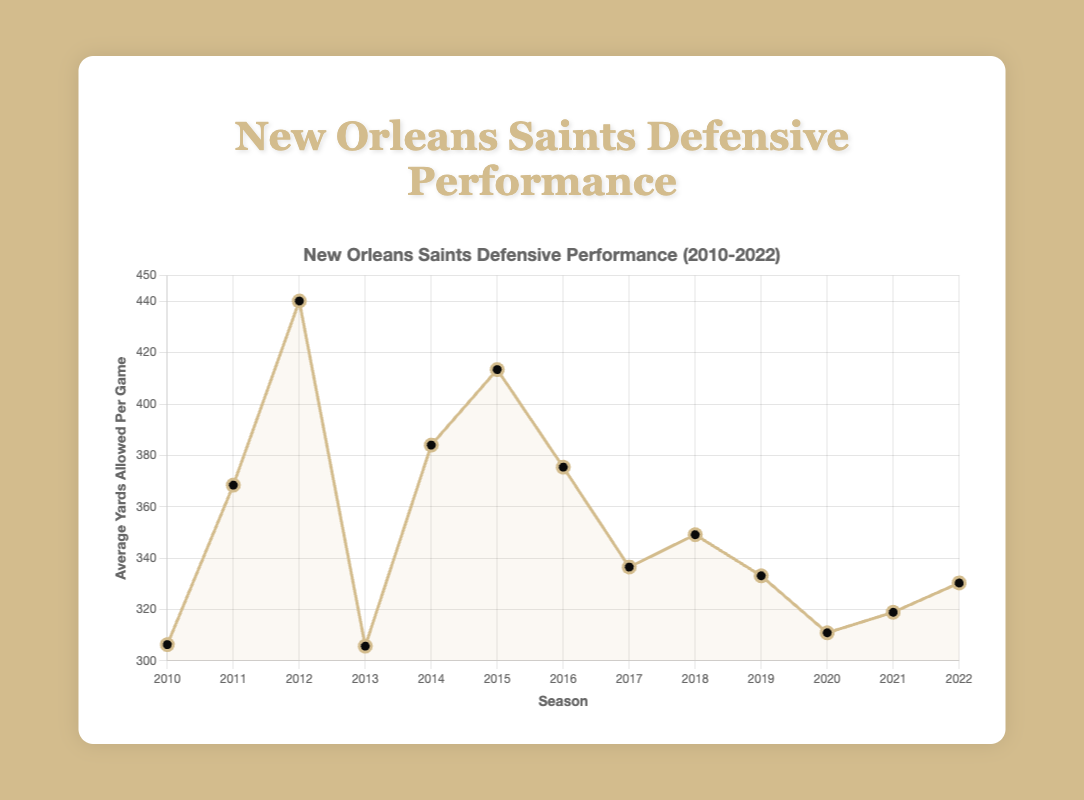What's the season with the highest average yards allowed per game? The highest average yards allowed per game can be found by looking at the peak of the line on the chart, which represents the most yards allowed. The highest point is around the season 2012, showing 440.1 yards per game.
Answer: 2012 Between which two consecutive seasons did the Saints show the most improvement in yards allowed per game? Improvement in yards allowed per game means a decrease in the number of yards allowed. By visually comparing the slopes between adjacent data points, the steepest negative slope (largest drop) is between 2012 and 2013, where the value dropped from 440.1 to 305.7.
Answer: 2012 and 2013 How many seasons did the Saints allow fewer than 320 yards on average per game? This can be calculated by counting the number of data points on the chart that fall below the 320-yard mark. The seasons 2010, 2013, 2020, and 2021 are all below this value.
Answer: 4 By how much did the average yards allowed per game decrease from 2018 to 2019? To find the decrease, subtract the value for 2019 from the value for 2018. The values are 349.1 yards for 2018 and 333.1 yards for 2019, giving \(349.1 - 333.1 = 16\) yards.
Answer: 16 yards What is the average yards allowed per game across all seasons? Add up all the average yards allowed per game for each season, and then divide by the number of seasons (13 total). \((306.3 + 368.4 + 440.1 + 305.7 + 384.0 + 413.4 + 375.4 + 336.5 + 349.1 + 333.1 + 310.9 + 318.9 + 330.3) / 13 \approx 352.9\).
Answer: 352.9 Are there any seasons where the average yards allowed per game stayed the same as the previous season? Check the chart for any two consecutive points that lie horizontally aligned to indicate no change. According to the data points shown in the visualization, there are no two consecutive seasons with the same value.
Answer: No Which season showed a worse defensive performance compared to 2014? Compare the average yards allowed per game in 2014 (384.0) with the other seasons. The seasons 2012 (440.1), 2015 (413.4), and 2014 itself are all higher than 384.0.
Answer: 2012 and 2015 